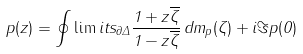Convert formula to latex. <formula><loc_0><loc_0><loc_500><loc_500>p ( z ) = \oint \lim i t s _ { \partial \Delta } \frac { 1 + z \overline { \zeta } } { 1 - z \overline { \zeta } } \, d m _ { p } ( \zeta ) + i \Im p ( 0 )</formula> 